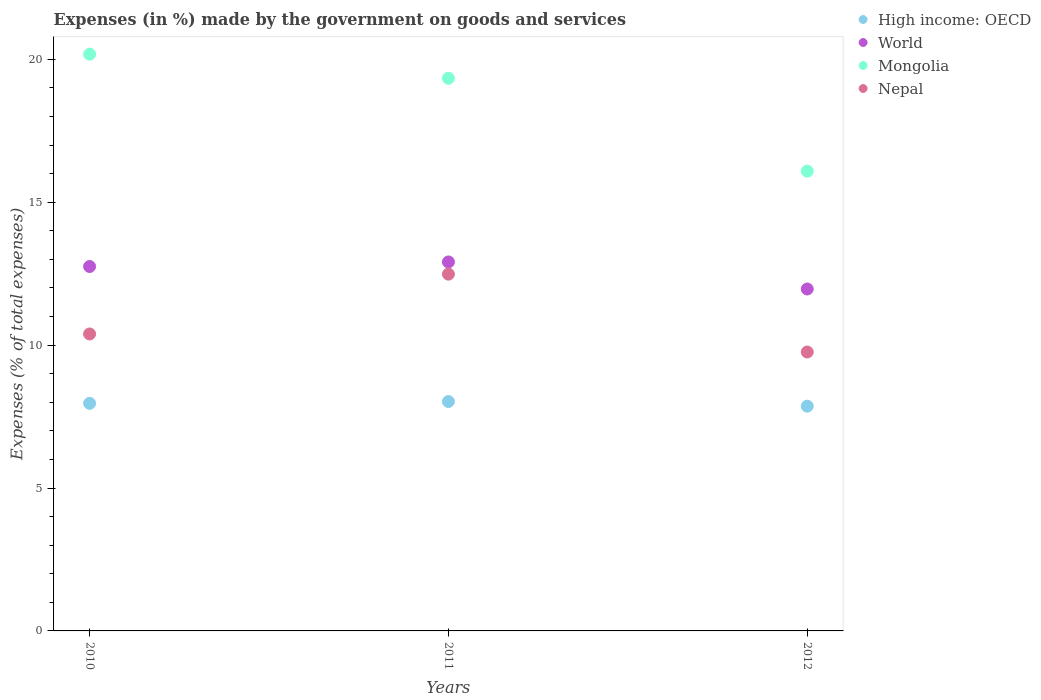How many different coloured dotlines are there?
Keep it short and to the point. 4. Is the number of dotlines equal to the number of legend labels?
Make the answer very short. Yes. What is the percentage of expenses made by the government on goods and services in Nepal in 2011?
Keep it short and to the point. 12.49. Across all years, what is the maximum percentage of expenses made by the government on goods and services in Nepal?
Provide a succinct answer. 12.49. Across all years, what is the minimum percentage of expenses made by the government on goods and services in Nepal?
Your response must be concise. 9.76. In which year was the percentage of expenses made by the government on goods and services in Mongolia maximum?
Provide a short and direct response. 2010. What is the total percentage of expenses made by the government on goods and services in High income: OECD in the graph?
Make the answer very short. 23.86. What is the difference between the percentage of expenses made by the government on goods and services in World in 2011 and that in 2012?
Offer a terse response. 0.95. What is the difference between the percentage of expenses made by the government on goods and services in Nepal in 2011 and the percentage of expenses made by the government on goods and services in High income: OECD in 2012?
Give a very brief answer. 4.62. What is the average percentage of expenses made by the government on goods and services in Mongolia per year?
Your response must be concise. 18.54. In the year 2011, what is the difference between the percentage of expenses made by the government on goods and services in Mongolia and percentage of expenses made by the government on goods and services in World?
Offer a very short reply. 6.43. What is the ratio of the percentage of expenses made by the government on goods and services in Mongolia in 2010 to that in 2011?
Keep it short and to the point. 1.04. Is the percentage of expenses made by the government on goods and services in High income: OECD in 2010 less than that in 2012?
Give a very brief answer. No. Is the difference between the percentage of expenses made by the government on goods and services in Mongolia in 2010 and 2011 greater than the difference between the percentage of expenses made by the government on goods and services in World in 2010 and 2011?
Your response must be concise. Yes. What is the difference between the highest and the second highest percentage of expenses made by the government on goods and services in Mongolia?
Your answer should be very brief. 0.84. What is the difference between the highest and the lowest percentage of expenses made by the government on goods and services in Mongolia?
Give a very brief answer. 4.09. Is the sum of the percentage of expenses made by the government on goods and services in High income: OECD in 2011 and 2012 greater than the maximum percentage of expenses made by the government on goods and services in World across all years?
Provide a succinct answer. Yes. Is it the case that in every year, the sum of the percentage of expenses made by the government on goods and services in High income: OECD and percentage of expenses made by the government on goods and services in Nepal  is greater than the percentage of expenses made by the government on goods and services in Mongolia?
Provide a short and direct response. No. Is the percentage of expenses made by the government on goods and services in Nepal strictly greater than the percentage of expenses made by the government on goods and services in World over the years?
Your answer should be very brief. No. How many dotlines are there?
Your response must be concise. 4. How many years are there in the graph?
Provide a succinct answer. 3. What is the difference between two consecutive major ticks on the Y-axis?
Offer a terse response. 5. Are the values on the major ticks of Y-axis written in scientific E-notation?
Your answer should be very brief. No. Does the graph contain any zero values?
Provide a succinct answer. No. How are the legend labels stacked?
Ensure brevity in your answer.  Vertical. What is the title of the graph?
Keep it short and to the point. Expenses (in %) made by the government on goods and services. What is the label or title of the Y-axis?
Ensure brevity in your answer.  Expenses (% of total expenses). What is the Expenses (% of total expenses) of High income: OECD in 2010?
Offer a terse response. 7.96. What is the Expenses (% of total expenses) of World in 2010?
Give a very brief answer. 12.75. What is the Expenses (% of total expenses) in Mongolia in 2010?
Provide a short and direct response. 20.18. What is the Expenses (% of total expenses) of Nepal in 2010?
Make the answer very short. 10.39. What is the Expenses (% of total expenses) of High income: OECD in 2011?
Give a very brief answer. 8.03. What is the Expenses (% of total expenses) in World in 2011?
Offer a very short reply. 12.91. What is the Expenses (% of total expenses) in Mongolia in 2011?
Your response must be concise. 19.34. What is the Expenses (% of total expenses) of Nepal in 2011?
Your response must be concise. 12.49. What is the Expenses (% of total expenses) of High income: OECD in 2012?
Offer a terse response. 7.86. What is the Expenses (% of total expenses) of World in 2012?
Provide a succinct answer. 11.96. What is the Expenses (% of total expenses) of Mongolia in 2012?
Offer a very short reply. 16.09. What is the Expenses (% of total expenses) in Nepal in 2012?
Provide a succinct answer. 9.76. Across all years, what is the maximum Expenses (% of total expenses) of High income: OECD?
Provide a short and direct response. 8.03. Across all years, what is the maximum Expenses (% of total expenses) in World?
Keep it short and to the point. 12.91. Across all years, what is the maximum Expenses (% of total expenses) in Mongolia?
Your answer should be very brief. 20.18. Across all years, what is the maximum Expenses (% of total expenses) of Nepal?
Make the answer very short. 12.49. Across all years, what is the minimum Expenses (% of total expenses) in High income: OECD?
Your response must be concise. 7.86. Across all years, what is the minimum Expenses (% of total expenses) of World?
Ensure brevity in your answer.  11.96. Across all years, what is the minimum Expenses (% of total expenses) in Mongolia?
Ensure brevity in your answer.  16.09. Across all years, what is the minimum Expenses (% of total expenses) in Nepal?
Ensure brevity in your answer.  9.76. What is the total Expenses (% of total expenses) of High income: OECD in the graph?
Provide a succinct answer. 23.86. What is the total Expenses (% of total expenses) in World in the graph?
Give a very brief answer. 37.63. What is the total Expenses (% of total expenses) in Mongolia in the graph?
Provide a succinct answer. 55.61. What is the total Expenses (% of total expenses) of Nepal in the graph?
Your answer should be very brief. 32.64. What is the difference between the Expenses (% of total expenses) in High income: OECD in 2010 and that in 2011?
Give a very brief answer. -0.06. What is the difference between the Expenses (% of total expenses) of World in 2010 and that in 2011?
Your response must be concise. -0.16. What is the difference between the Expenses (% of total expenses) in Mongolia in 2010 and that in 2011?
Offer a terse response. 0.84. What is the difference between the Expenses (% of total expenses) in Nepal in 2010 and that in 2011?
Provide a succinct answer. -2.09. What is the difference between the Expenses (% of total expenses) in High income: OECD in 2010 and that in 2012?
Offer a very short reply. 0.1. What is the difference between the Expenses (% of total expenses) of World in 2010 and that in 2012?
Offer a terse response. 0.79. What is the difference between the Expenses (% of total expenses) of Mongolia in 2010 and that in 2012?
Give a very brief answer. 4.09. What is the difference between the Expenses (% of total expenses) in Nepal in 2010 and that in 2012?
Your answer should be very brief. 0.63. What is the difference between the Expenses (% of total expenses) in High income: OECD in 2011 and that in 2012?
Make the answer very short. 0.16. What is the difference between the Expenses (% of total expenses) in World in 2011 and that in 2012?
Give a very brief answer. 0.95. What is the difference between the Expenses (% of total expenses) of Mongolia in 2011 and that in 2012?
Keep it short and to the point. 3.25. What is the difference between the Expenses (% of total expenses) of Nepal in 2011 and that in 2012?
Ensure brevity in your answer.  2.73. What is the difference between the Expenses (% of total expenses) of High income: OECD in 2010 and the Expenses (% of total expenses) of World in 2011?
Ensure brevity in your answer.  -4.95. What is the difference between the Expenses (% of total expenses) in High income: OECD in 2010 and the Expenses (% of total expenses) in Mongolia in 2011?
Offer a terse response. -11.37. What is the difference between the Expenses (% of total expenses) in High income: OECD in 2010 and the Expenses (% of total expenses) in Nepal in 2011?
Keep it short and to the point. -4.52. What is the difference between the Expenses (% of total expenses) of World in 2010 and the Expenses (% of total expenses) of Mongolia in 2011?
Give a very brief answer. -6.59. What is the difference between the Expenses (% of total expenses) of World in 2010 and the Expenses (% of total expenses) of Nepal in 2011?
Ensure brevity in your answer.  0.27. What is the difference between the Expenses (% of total expenses) of Mongolia in 2010 and the Expenses (% of total expenses) of Nepal in 2011?
Your answer should be very brief. 7.7. What is the difference between the Expenses (% of total expenses) of High income: OECD in 2010 and the Expenses (% of total expenses) of World in 2012?
Provide a short and direct response. -4. What is the difference between the Expenses (% of total expenses) of High income: OECD in 2010 and the Expenses (% of total expenses) of Mongolia in 2012?
Your answer should be compact. -8.12. What is the difference between the Expenses (% of total expenses) of High income: OECD in 2010 and the Expenses (% of total expenses) of Nepal in 2012?
Provide a succinct answer. -1.8. What is the difference between the Expenses (% of total expenses) in World in 2010 and the Expenses (% of total expenses) in Mongolia in 2012?
Provide a succinct answer. -3.34. What is the difference between the Expenses (% of total expenses) in World in 2010 and the Expenses (% of total expenses) in Nepal in 2012?
Ensure brevity in your answer.  2.99. What is the difference between the Expenses (% of total expenses) in Mongolia in 2010 and the Expenses (% of total expenses) in Nepal in 2012?
Your answer should be compact. 10.42. What is the difference between the Expenses (% of total expenses) in High income: OECD in 2011 and the Expenses (% of total expenses) in World in 2012?
Provide a short and direct response. -3.94. What is the difference between the Expenses (% of total expenses) in High income: OECD in 2011 and the Expenses (% of total expenses) in Mongolia in 2012?
Make the answer very short. -8.06. What is the difference between the Expenses (% of total expenses) in High income: OECD in 2011 and the Expenses (% of total expenses) in Nepal in 2012?
Your answer should be very brief. -1.73. What is the difference between the Expenses (% of total expenses) in World in 2011 and the Expenses (% of total expenses) in Mongolia in 2012?
Provide a succinct answer. -3.18. What is the difference between the Expenses (% of total expenses) in World in 2011 and the Expenses (% of total expenses) in Nepal in 2012?
Keep it short and to the point. 3.15. What is the difference between the Expenses (% of total expenses) in Mongolia in 2011 and the Expenses (% of total expenses) in Nepal in 2012?
Make the answer very short. 9.58. What is the average Expenses (% of total expenses) in High income: OECD per year?
Offer a very short reply. 7.95. What is the average Expenses (% of total expenses) in World per year?
Make the answer very short. 12.54. What is the average Expenses (% of total expenses) in Mongolia per year?
Make the answer very short. 18.54. What is the average Expenses (% of total expenses) in Nepal per year?
Your answer should be very brief. 10.88. In the year 2010, what is the difference between the Expenses (% of total expenses) of High income: OECD and Expenses (% of total expenses) of World?
Keep it short and to the point. -4.79. In the year 2010, what is the difference between the Expenses (% of total expenses) in High income: OECD and Expenses (% of total expenses) in Mongolia?
Offer a very short reply. -12.22. In the year 2010, what is the difference between the Expenses (% of total expenses) in High income: OECD and Expenses (% of total expenses) in Nepal?
Provide a succinct answer. -2.43. In the year 2010, what is the difference between the Expenses (% of total expenses) of World and Expenses (% of total expenses) of Mongolia?
Make the answer very short. -7.43. In the year 2010, what is the difference between the Expenses (% of total expenses) of World and Expenses (% of total expenses) of Nepal?
Make the answer very short. 2.36. In the year 2010, what is the difference between the Expenses (% of total expenses) in Mongolia and Expenses (% of total expenses) in Nepal?
Keep it short and to the point. 9.79. In the year 2011, what is the difference between the Expenses (% of total expenses) of High income: OECD and Expenses (% of total expenses) of World?
Ensure brevity in your answer.  -4.88. In the year 2011, what is the difference between the Expenses (% of total expenses) of High income: OECD and Expenses (% of total expenses) of Mongolia?
Offer a very short reply. -11.31. In the year 2011, what is the difference between the Expenses (% of total expenses) in High income: OECD and Expenses (% of total expenses) in Nepal?
Ensure brevity in your answer.  -4.46. In the year 2011, what is the difference between the Expenses (% of total expenses) in World and Expenses (% of total expenses) in Mongolia?
Give a very brief answer. -6.43. In the year 2011, what is the difference between the Expenses (% of total expenses) in World and Expenses (% of total expenses) in Nepal?
Keep it short and to the point. 0.43. In the year 2011, what is the difference between the Expenses (% of total expenses) in Mongolia and Expenses (% of total expenses) in Nepal?
Offer a terse response. 6.85. In the year 2012, what is the difference between the Expenses (% of total expenses) in High income: OECD and Expenses (% of total expenses) in World?
Ensure brevity in your answer.  -4.1. In the year 2012, what is the difference between the Expenses (% of total expenses) of High income: OECD and Expenses (% of total expenses) of Mongolia?
Your answer should be very brief. -8.22. In the year 2012, what is the difference between the Expenses (% of total expenses) of High income: OECD and Expenses (% of total expenses) of Nepal?
Offer a very short reply. -1.9. In the year 2012, what is the difference between the Expenses (% of total expenses) in World and Expenses (% of total expenses) in Mongolia?
Offer a very short reply. -4.12. In the year 2012, what is the difference between the Expenses (% of total expenses) of World and Expenses (% of total expenses) of Nepal?
Make the answer very short. 2.2. In the year 2012, what is the difference between the Expenses (% of total expenses) of Mongolia and Expenses (% of total expenses) of Nepal?
Offer a terse response. 6.33. What is the ratio of the Expenses (% of total expenses) of High income: OECD in 2010 to that in 2011?
Your response must be concise. 0.99. What is the ratio of the Expenses (% of total expenses) of World in 2010 to that in 2011?
Provide a succinct answer. 0.99. What is the ratio of the Expenses (% of total expenses) of Mongolia in 2010 to that in 2011?
Provide a succinct answer. 1.04. What is the ratio of the Expenses (% of total expenses) of Nepal in 2010 to that in 2011?
Your response must be concise. 0.83. What is the ratio of the Expenses (% of total expenses) in High income: OECD in 2010 to that in 2012?
Keep it short and to the point. 1.01. What is the ratio of the Expenses (% of total expenses) in World in 2010 to that in 2012?
Provide a succinct answer. 1.07. What is the ratio of the Expenses (% of total expenses) of Mongolia in 2010 to that in 2012?
Ensure brevity in your answer.  1.25. What is the ratio of the Expenses (% of total expenses) in Nepal in 2010 to that in 2012?
Keep it short and to the point. 1.06. What is the ratio of the Expenses (% of total expenses) in High income: OECD in 2011 to that in 2012?
Your answer should be compact. 1.02. What is the ratio of the Expenses (% of total expenses) in World in 2011 to that in 2012?
Ensure brevity in your answer.  1.08. What is the ratio of the Expenses (% of total expenses) in Mongolia in 2011 to that in 2012?
Your answer should be very brief. 1.2. What is the ratio of the Expenses (% of total expenses) in Nepal in 2011 to that in 2012?
Offer a terse response. 1.28. What is the difference between the highest and the second highest Expenses (% of total expenses) in High income: OECD?
Your answer should be compact. 0.06. What is the difference between the highest and the second highest Expenses (% of total expenses) in World?
Provide a succinct answer. 0.16. What is the difference between the highest and the second highest Expenses (% of total expenses) of Mongolia?
Your answer should be very brief. 0.84. What is the difference between the highest and the second highest Expenses (% of total expenses) in Nepal?
Keep it short and to the point. 2.09. What is the difference between the highest and the lowest Expenses (% of total expenses) in High income: OECD?
Provide a short and direct response. 0.16. What is the difference between the highest and the lowest Expenses (% of total expenses) in World?
Your answer should be compact. 0.95. What is the difference between the highest and the lowest Expenses (% of total expenses) in Mongolia?
Offer a terse response. 4.09. What is the difference between the highest and the lowest Expenses (% of total expenses) of Nepal?
Provide a short and direct response. 2.73. 